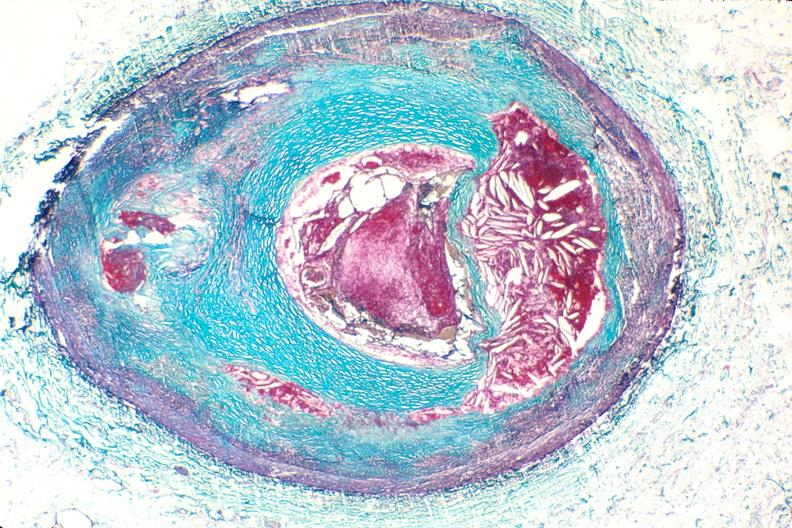s tuberculosis present?
Answer the question using a single word or phrase. No 